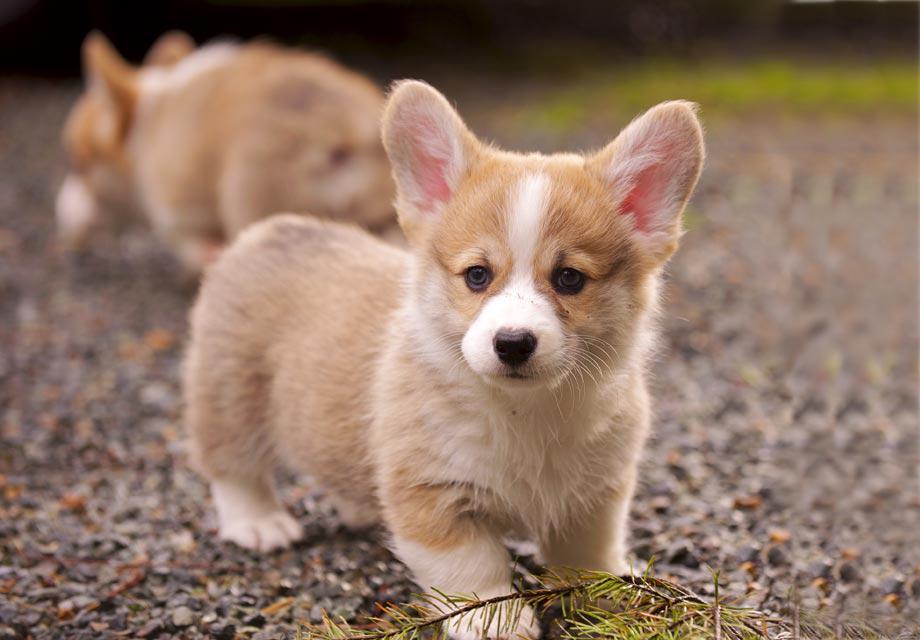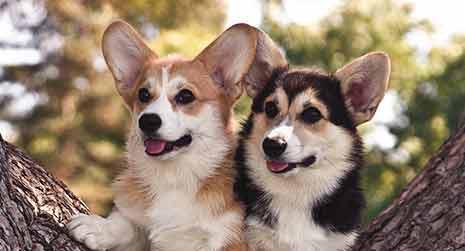The first image is the image on the left, the second image is the image on the right. For the images shown, is this caption "An image shows a forward-facing dog with its mouth closed." true? Answer yes or no. Yes. The first image is the image on the left, the second image is the image on the right. Given the left and right images, does the statement "There is exactly two dogs in the right image." hold true? Answer yes or no. Yes. 